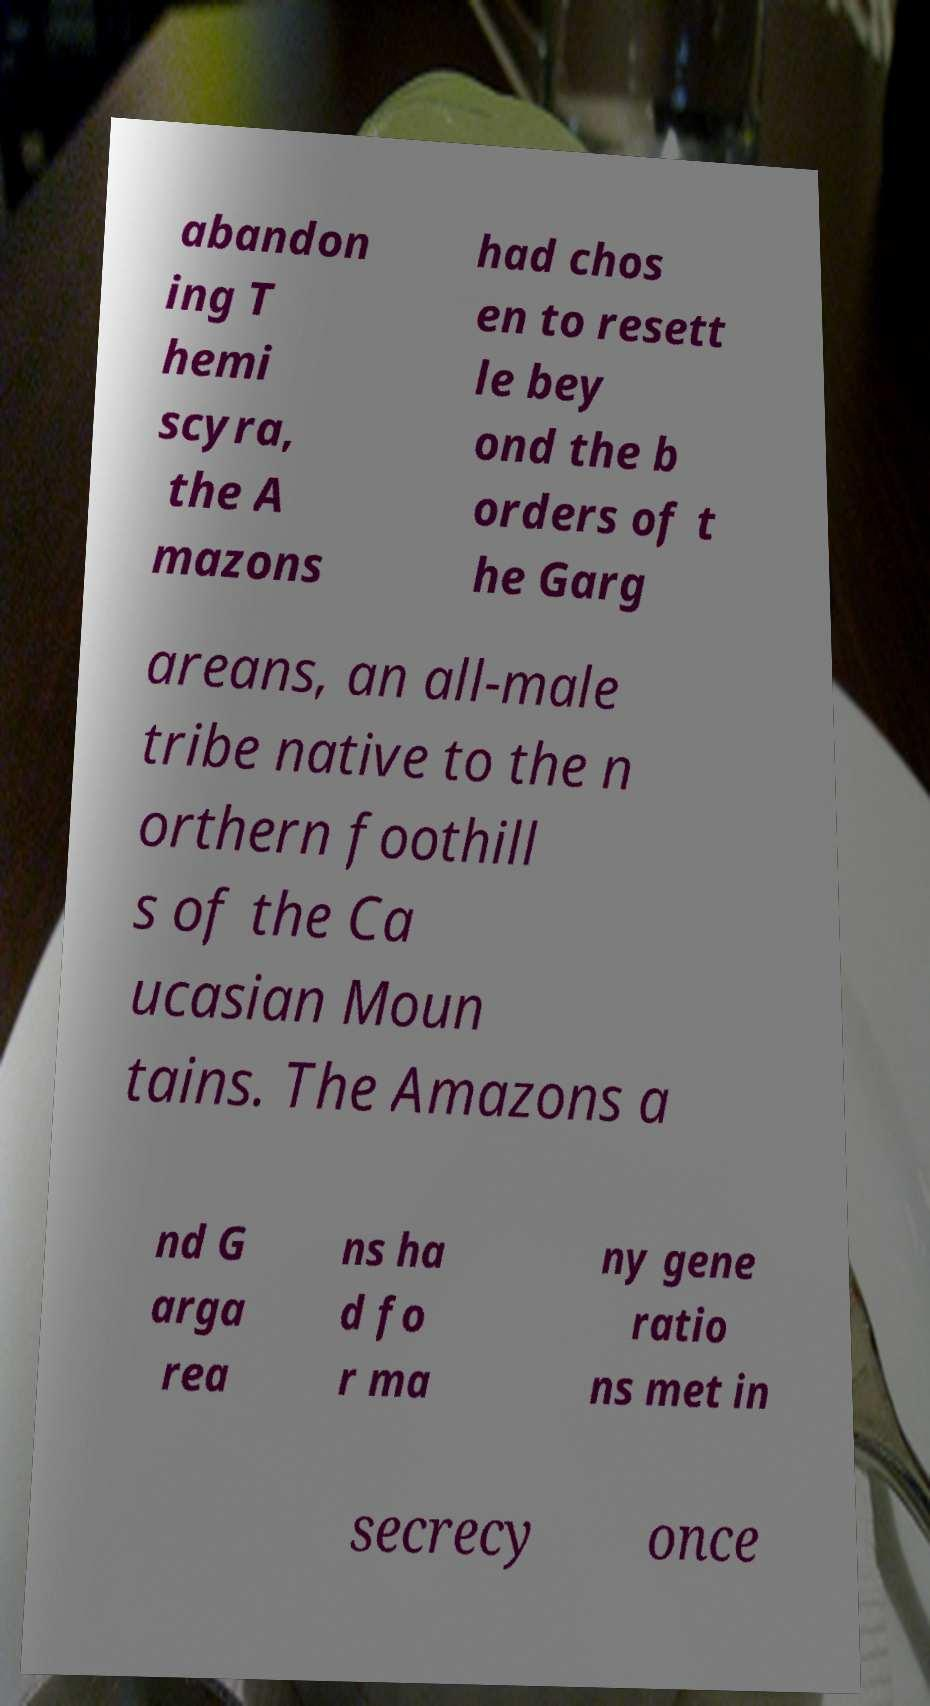There's text embedded in this image that I need extracted. Can you transcribe it verbatim? abandon ing T hemi scyra, the A mazons had chos en to resett le bey ond the b orders of t he Garg areans, an all-male tribe native to the n orthern foothill s of the Ca ucasian Moun tains. The Amazons a nd G arga rea ns ha d fo r ma ny gene ratio ns met in secrecy once 